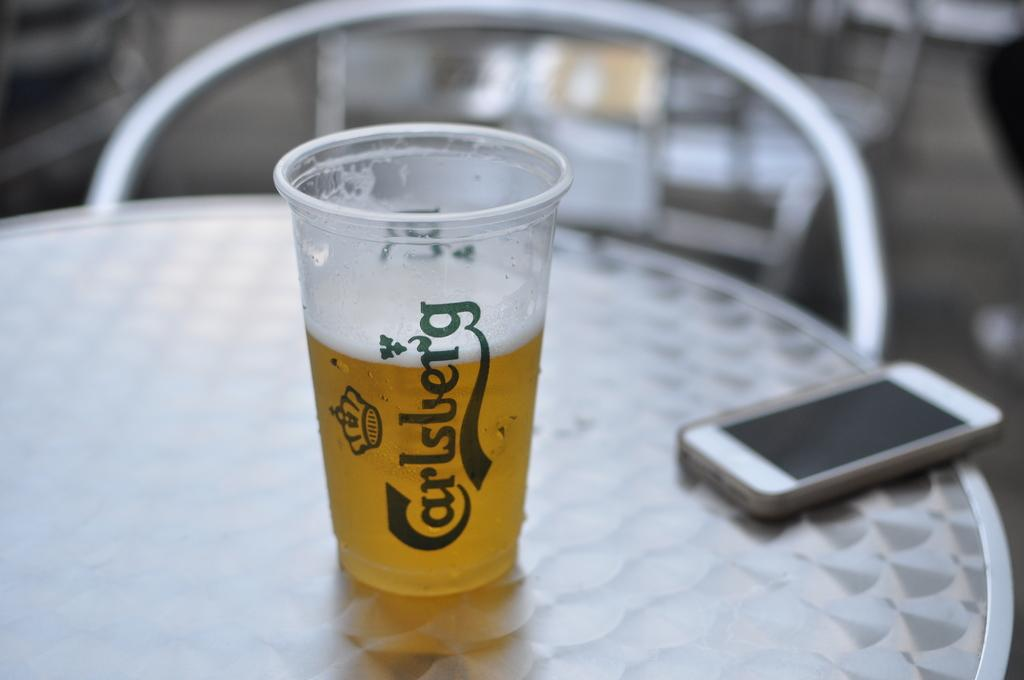<image>
Relay a brief, clear account of the picture shown. A half full cup of carlsberg beer on a table next to a white iphone in a case 